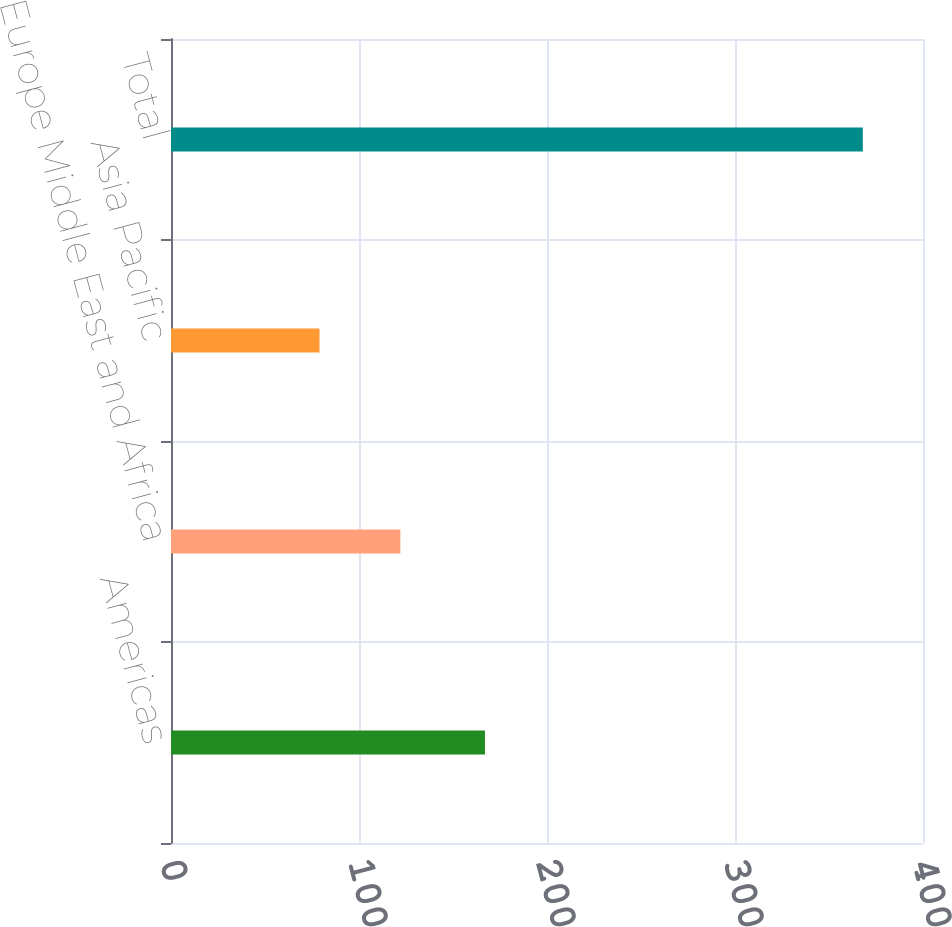Convert chart. <chart><loc_0><loc_0><loc_500><loc_500><bar_chart><fcel>Americas<fcel>Europe Middle East and Africa<fcel>Asia Pacific<fcel>Total<nl><fcel>167<fcel>122<fcel>79<fcel>368<nl></chart> 